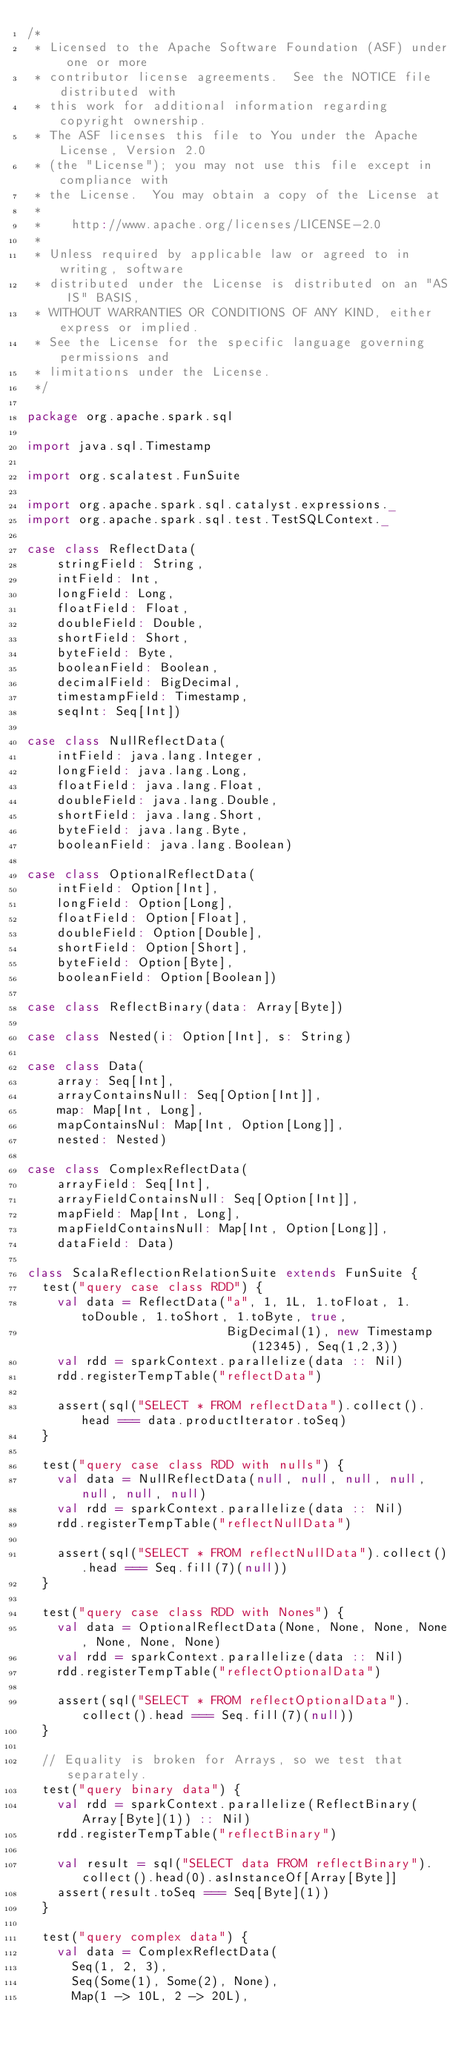Convert code to text. <code><loc_0><loc_0><loc_500><loc_500><_Scala_>/*
 * Licensed to the Apache Software Foundation (ASF) under one or more
 * contributor license agreements.  See the NOTICE file distributed with
 * this work for additional information regarding copyright ownership.
 * The ASF licenses this file to You under the Apache License, Version 2.0
 * (the "License"); you may not use this file except in compliance with
 * the License.  You may obtain a copy of the License at
 *
 *    http://www.apache.org/licenses/LICENSE-2.0
 *
 * Unless required by applicable law or agreed to in writing, software
 * distributed under the License is distributed on an "AS IS" BASIS,
 * WITHOUT WARRANTIES OR CONDITIONS OF ANY KIND, either express or implied.
 * See the License for the specific language governing permissions and
 * limitations under the License.
 */

package org.apache.spark.sql

import java.sql.Timestamp

import org.scalatest.FunSuite

import org.apache.spark.sql.catalyst.expressions._
import org.apache.spark.sql.test.TestSQLContext._

case class ReflectData(
    stringField: String,
    intField: Int,
    longField: Long,
    floatField: Float,
    doubleField: Double,
    shortField: Short,
    byteField: Byte,
    booleanField: Boolean,
    decimalField: BigDecimal,
    timestampField: Timestamp,
    seqInt: Seq[Int])

case class NullReflectData(
    intField: java.lang.Integer,
    longField: java.lang.Long,
    floatField: java.lang.Float,
    doubleField: java.lang.Double,
    shortField: java.lang.Short,
    byteField: java.lang.Byte,
    booleanField: java.lang.Boolean)

case class OptionalReflectData(
    intField: Option[Int],
    longField: Option[Long],
    floatField: Option[Float],
    doubleField: Option[Double],
    shortField: Option[Short],
    byteField: Option[Byte],
    booleanField: Option[Boolean])

case class ReflectBinary(data: Array[Byte])

case class Nested(i: Option[Int], s: String)

case class Data(
    array: Seq[Int],
    arrayContainsNull: Seq[Option[Int]],
    map: Map[Int, Long],
    mapContainsNul: Map[Int, Option[Long]],
    nested: Nested)

case class ComplexReflectData(
    arrayField: Seq[Int],
    arrayFieldContainsNull: Seq[Option[Int]],
    mapField: Map[Int, Long],
    mapFieldContainsNull: Map[Int, Option[Long]],
    dataField: Data)

class ScalaReflectionRelationSuite extends FunSuite {
  test("query case class RDD") {
    val data = ReflectData("a", 1, 1L, 1.toFloat, 1.toDouble, 1.toShort, 1.toByte, true,
                           BigDecimal(1), new Timestamp(12345), Seq(1,2,3))
    val rdd = sparkContext.parallelize(data :: Nil)
    rdd.registerTempTable("reflectData")

    assert(sql("SELECT * FROM reflectData").collect().head === data.productIterator.toSeq)
  }

  test("query case class RDD with nulls") {
    val data = NullReflectData(null, null, null, null, null, null, null)
    val rdd = sparkContext.parallelize(data :: Nil)
    rdd.registerTempTable("reflectNullData")

    assert(sql("SELECT * FROM reflectNullData").collect().head === Seq.fill(7)(null))
  }

  test("query case class RDD with Nones") {
    val data = OptionalReflectData(None, None, None, None, None, None, None)
    val rdd = sparkContext.parallelize(data :: Nil)
    rdd.registerTempTable("reflectOptionalData")

    assert(sql("SELECT * FROM reflectOptionalData").collect().head === Seq.fill(7)(null))
  }

  // Equality is broken for Arrays, so we test that separately.
  test("query binary data") {
    val rdd = sparkContext.parallelize(ReflectBinary(Array[Byte](1)) :: Nil)
    rdd.registerTempTable("reflectBinary")

    val result = sql("SELECT data FROM reflectBinary").collect().head(0).asInstanceOf[Array[Byte]]
    assert(result.toSeq === Seq[Byte](1))
  }

  test("query complex data") {
    val data = ComplexReflectData(
      Seq(1, 2, 3),
      Seq(Some(1), Some(2), None),
      Map(1 -> 10L, 2 -> 20L),</code> 